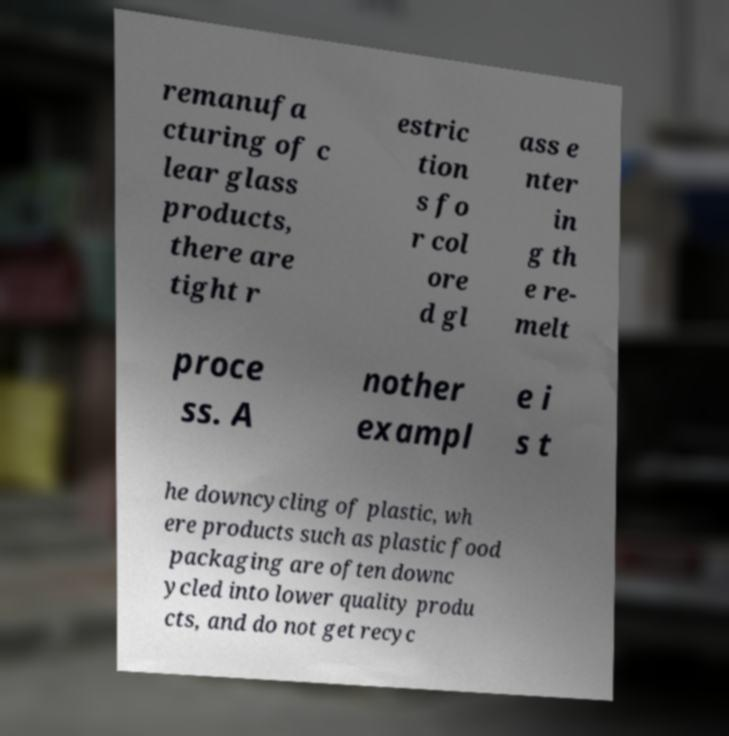Can you read and provide the text displayed in the image?This photo seems to have some interesting text. Can you extract and type it out for me? remanufa cturing of c lear glass products, there are tight r estric tion s fo r col ore d gl ass e nter in g th e re- melt proce ss. A nother exampl e i s t he downcycling of plastic, wh ere products such as plastic food packaging are often downc ycled into lower quality produ cts, and do not get recyc 